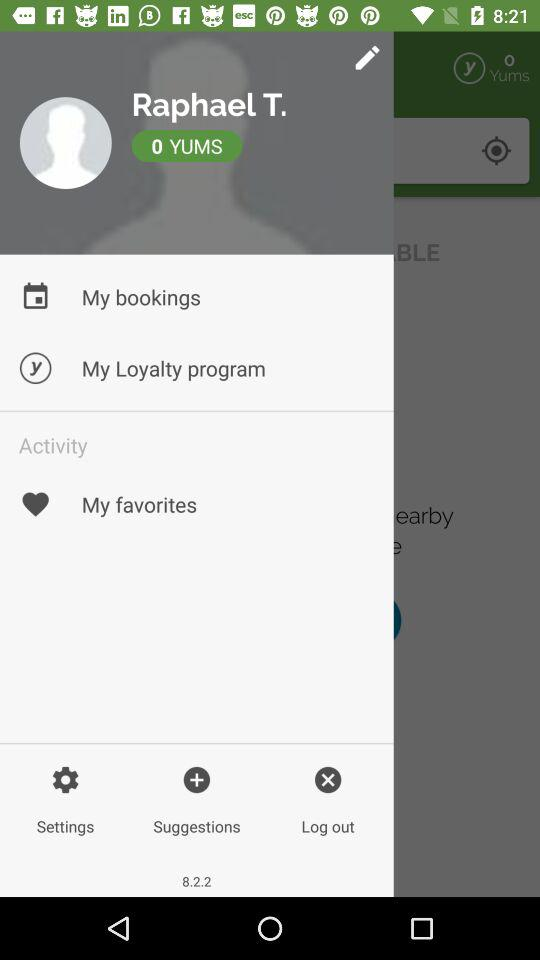How many yums are there? There are 0 yums. 